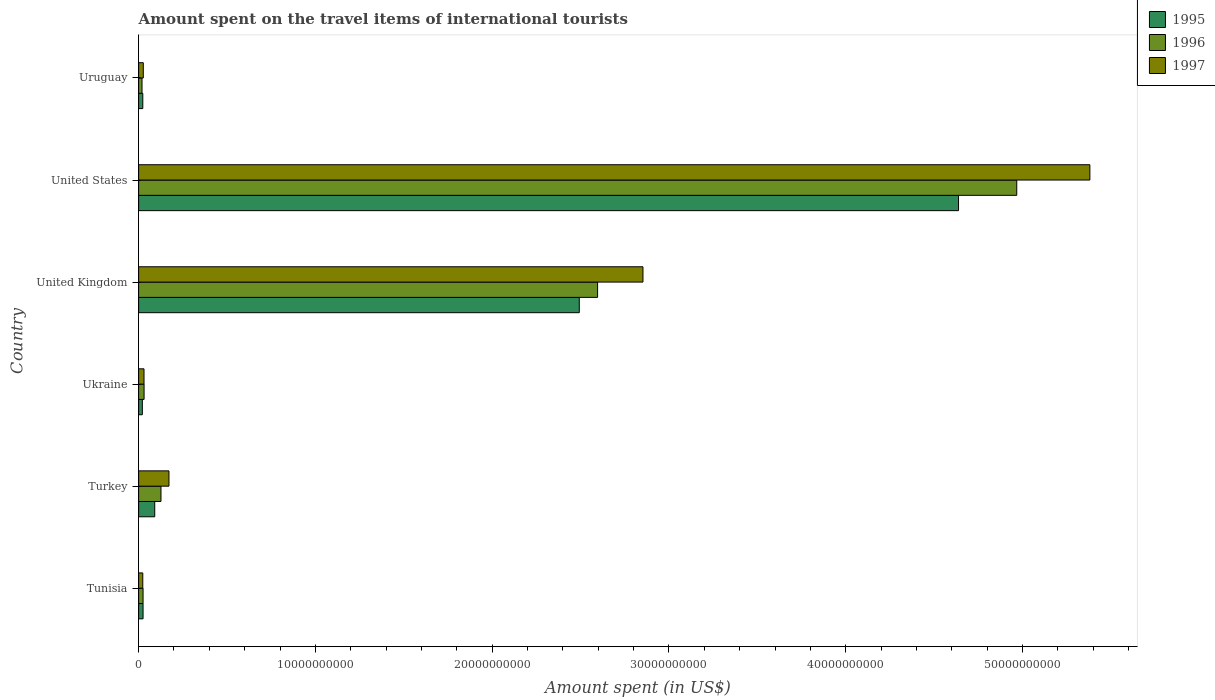How many different coloured bars are there?
Your answer should be very brief. 3. How many groups of bars are there?
Give a very brief answer. 6. How many bars are there on the 6th tick from the top?
Your response must be concise. 3. What is the label of the 3rd group of bars from the top?
Offer a very short reply. United Kingdom. What is the amount spent on the travel items of international tourists in 1996 in Turkey?
Offer a terse response. 1.26e+09. Across all countries, what is the maximum amount spent on the travel items of international tourists in 1996?
Provide a succinct answer. 4.97e+1. Across all countries, what is the minimum amount spent on the travel items of international tourists in 1996?
Your answer should be compact. 1.92e+08. In which country was the amount spent on the travel items of international tourists in 1996 minimum?
Offer a terse response. Uruguay. What is the total amount spent on the travel items of international tourists in 1995 in the graph?
Your response must be concise. 7.29e+1. What is the difference between the amount spent on the travel items of international tourists in 1996 in Ukraine and that in United Kingdom?
Ensure brevity in your answer.  -2.57e+1. What is the difference between the amount spent on the travel items of international tourists in 1997 in United Kingdom and the amount spent on the travel items of international tourists in 1995 in Turkey?
Offer a very short reply. 2.76e+1. What is the average amount spent on the travel items of international tourists in 1996 per country?
Ensure brevity in your answer.  1.29e+1. What is the difference between the amount spent on the travel items of international tourists in 1995 and amount spent on the travel items of international tourists in 1996 in Uruguay?
Offer a very short reply. 4.40e+07. What is the ratio of the amount spent on the travel items of international tourists in 1997 in Turkey to that in United Kingdom?
Make the answer very short. 0.06. What is the difference between the highest and the second highest amount spent on the travel items of international tourists in 1996?
Provide a succinct answer. 2.37e+1. What is the difference between the highest and the lowest amount spent on the travel items of international tourists in 1997?
Offer a very short reply. 5.36e+1. In how many countries, is the amount spent on the travel items of international tourists in 1996 greater than the average amount spent on the travel items of international tourists in 1996 taken over all countries?
Keep it short and to the point. 2. What does the 3rd bar from the top in Ukraine represents?
Make the answer very short. 1995. Are all the bars in the graph horizontal?
Provide a short and direct response. Yes. How many countries are there in the graph?
Your answer should be compact. 6. Are the values on the major ticks of X-axis written in scientific E-notation?
Your response must be concise. No. Does the graph contain any zero values?
Provide a succinct answer. No. Where does the legend appear in the graph?
Your answer should be compact. Top right. How many legend labels are there?
Your answer should be very brief. 3. How are the legend labels stacked?
Offer a very short reply. Vertical. What is the title of the graph?
Ensure brevity in your answer.  Amount spent on the travel items of international tourists. What is the label or title of the X-axis?
Keep it short and to the point. Amount spent (in US$). What is the Amount spent (in US$) in 1995 in Tunisia?
Provide a short and direct response. 2.51e+08. What is the Amount spent (in US$) in 1996 in Tunisia?
Your answer should be compact. 2.51e+08. What is the Amount spent (in US$) in 1997 in Tunisia?
Your answer should be compact. 2.35e+08. What is the Amount spent (in US$) in 1995 in Turkey?
Your answer should be very brief. 9.11e+08. What is the Amount spent (in US$) in 1996 in Turkey?
Provide a succinct answer. 1.26e+09. What is the Amount spent (in US$) of 1997 in Turkey?
Provide a short and direct response. 1.72e+09. What is the Amount spent (in US$) in 1995 in Ukraine?
Provide a succinct answer. 2.10e+08. What is the Amount spent (in US$) in 1996 in Ukraine?
Your response must be concise. 3.08e+08. What is the Amount spent (in US$) of 1997 in Ukraine?
Your answer should be very brief. 3.05e+08. What is the Amount spent (in US$) of 1995 in United Kingdom?
Keep it short and to the point. 2.49e+1. What is the Amount spent (in US$) in 1996 in United Kingdom?
Provide a short and direct response. 2.60e+1. What is the Amount spent (in US$) of 1997 in United Kingdom?
Give a very brief answer. 2.85e+1. What is the Amount spent (in US$) in 1995 in United States?
Your answer should be very brief. 4.64e+1. What is the Amount spent (in US$) in 1996 in United States?
Your answer should be very brief. 4.97e+1. What is the Amount spent (in US$) in 1997 in United States?
Your response must be concise. 5.38e+1. What is the Amount spent (in US$) in 1995 in Uruguay?
Your answer should be very brief. 2.36e+08. What is the Amount spent (in US$) of 1996 in Uruguay?
Provide a short and direct response. 1.92e+08. What is the Amount spent (in US$) of 1997 in Uruguay?
Give a very brief answer. 2.64e+08. Across all countries, what is the maximum Amount spent (in US$) in 1995?
Your response must be concise. 4.64e+1. Across all countries, what is the maximum Amount spent (in US$) in 1996?
Offer a very short reply. 4.97e+1. Across all countries, what is the maximum Amount spent (in US$) in 1997?
Your answer should be compact. 5.38e+1. Across all countries, what is the minimum Amount spent (in US$) in 1995?
Provide a succinct answer. 2.10e+08. Across all countries, what is the minimum Amount spent (in US$) of 1996?
Your response must be concise. 1.92e+08. Across all countries, what is the minimum Amount spent (in US$) of 1997?
Offer a very short reply. 2.35e+08. What is the total Amount spent (in US$) of 1995 in the graph?
Your response must be concise. 7.29e+1. What is the total Amount spent (in US$) of 1996 in the graph?
Your answer should be compact. 7.76e+1. What is the total Amount spent (in US$) in 1997 in the graph?
Your response must be concise. 8.49e+1. What is the difference between the Amount spent (in US$) of 1995 in Tunisia and that in Turkey?
Offer a very short reply. -6.60e+08. What is the difference between the Amount spent (in US$) of 1996 in Tunisia and that in Turkey?
Your answer should be very brief. -1.01e+09. What is the difference between the Amount spent (in US$) in 1997 in Tunisia and that in Turkey?
Give a very brief answer. -1.48e+09. What is the difference between the Amount spent (in US$) of 1995 in Tunisia and that in Ukraine?
Your response must be concise. 4.10e+07. What is the difference between the Amount spent (in US$) of 1996 in Tunisia and that in Ukraine?
Provide a succinct answer. -5.70e+07. What is the difference between the Amount spent (in US$) in 1997 in Tunisia and that in Ukraine?
Give a very brief answer. -7.00e+07. What is the difference between the Amount spent (in US$) of 1995 in Tunisia and that in United Kingdom?
Your response must be concise. -2.47e+1. What is the difference between the Amount spent (in US$) in 1996 in Tunisia and that in United Kingdom?
Offer a terse response. -2.57e+1. What is the difference between the Amount spent (in US$) of 1997 in Tunisia and that in United Kingdom?
Your answer should be compact. -2.83e+1. What is the difference between the Amount spent (in US$) in 1995 in Tunisia and that in United States?
Provide a succinct answer. -4.61e+1. What is the difference between the Amount spent (in US$) of 1996 in Tunisia and that in United States?
Offer a terse response. -4.94e+1. What is the difference between the Amount spent (in US$) in 1997 in Tunisia and that in United States?
Offer a very short reply. -5.36e+1. What is the difference between the Amount spent (in US$) of 1995 in Tunisia and that in Uruguay?
Give a very brief answer. 1.50e+07. What is the difference between the Amount spent (in US$) of 1996 in Tunisia and that in Uruguay?
Offer a very short reply. 5.90e+07. What is the difference between the Amount spent (in US$) of 1997 in Tunisia and that in Uruguay?
Provide a short and direct response. -2.90e+07. What is the difference between the Amount spent (in US$) of 1995 in Turkey and that in Ukraine?
Your response must be concise. 7.01e+08. What is the difference between the Amount spent (in US$) in 1996 in Turkey and that in Ukraine?
Ensure brevity in your answer.  9.57e+08. What is the difference between the Amount spent (in US$) of 1997 in Turkey and that in Ukraine?
Ensure brevity in your answer.  1.41e+09. What is the difference between the Amount spent (in US$) in 1995 in Turkey and that in United Kingdom?
Ensure brevity in your answer.  -2.40e+1. What is the difference between the Amount spent (in US$) in 1996 in Turkey and that in United Kingdom?
Your answer should be very brief. -2.47e+1. What is the difference between the Amount spent (in US$) of 1997 in Turkey and that in United Kingdom?
Your answer should be very brief. -2.68e+1. What is the difference between the Amount spent (in US$) in 1995 in Turkey and that in United States?
Make the answer very short. -4.55e+1. What is the difference between the Amount spent (in US$) of 1996 in Turkey and that in United States?
Give a very brief answer. -4.84e+1. What is the difference between the Amount spent (in US$) of 1997 in Turkey and that in United States?
Your response must be concise. -5.21e+1. What is the difference between the Amount spent (in US$) of 1995 in Turkey and that in Uruguay?
Offer a terse response. 6.75e+08. What is the difference between the Amount spent (in US$) in 1996 in Turkey and that in Uruguay?
Make the answer very short. 1.07e+09. What is the difference between the Amount spent (in US$) of 1997 in Turkey and that in Uruguay?
Keep it short and to the point. 1.45e+09. What is the difference between the Amount spent (in US$) of 1995 in Ukraine and that in United Kingdom?
Offer a very short reply. -2.47e+1. What is the difference between the Amount spent (in US$) of 1996 in Ukraine and that in United Kingdom?
Keep it short and to the point. -2.57e+1. What is the difference between the Amount spent (in US$) in 1997 in Ukraine and that in United Kingdom?
Offer a terse response. -2.82e+1. What is the difference between the Amount spent (in US$) of 1995 in Ukraine and that in United States?
Ensure brevity in your answer.  -4.62e+1. What is the difference between the Amount spent (in US$) of 1996 in Ukraine and that in United States?
Your answer should be compact. -4.94e+1. What is the difference between the Amount spent (in US$) of 1997 in Ukraine and that in United States?
Offer a very short reply. -5.35e+1. What is the difference between the Amount spent (in US$) in 1995 in Ukraine and that in Uruguay?
Your response must be concise. -2.60e+07. What is the difference between the Amount spent (in US$) in 1996 in Ukraine and that in Uruguay?
Give a very brief answer. 1.16e+08. What is the difference between the Amount spent (in US$) in 1997 in Ukraine and that in Uruguay?
Give a very brief answer. 4.10e+07. What is the difference between the Amount spent (in US$) in 1995 in United Kingdom and that in United States?
Your answer should be compact. -2.15e+1. What is the difference between the Amount spent (in US$) of 1996 in United Kingdom and that in United States?
Provide a short and direct response. -2.37e+1. What is the difference between the Amount spent (in US$) of 1997 in United Kingdom and that in United States?
Keep it short and to the point. -2.53e+1. What is the difference between the Amount spent (in US$) of 1995 in United Kingdom and that in Uruguay?
Give a very brief answer. 2.47e+1. What is the difference between the Amount spent (in US$) in 1996 in United Kingdom and that in Uruguay?
Offer a terse response. 2.58e+1. What is the difference between the Amount spent (in US$) in 1997 in United Kingdom and that in Uruguay?
Your answer should be very brief. 2.83e+1. What is the difference between the Amount spent (in US$) of 1995 in United States and that in Uruguay?
Offer a very short reply. 4.61e+1. What is the difference between the Amount spent (in US$) of 1996 in United States and that in Uruguay?
Your answer should be very brief. 4.95e+1. What is the difference between the Amount spent (in US$) in 1997 in United States and that in Uruguay?
Ensure brevity in your answer.  5.35e+1. What is the difference between the Amount spent (in US$) of 1995 in Tunisia and the Amount spent (in US$) of 1996 in Turkey?
Provide a short and direct response. -1.01e+09. What is the difference between the Amount spent (in US$) of 1995 in Tunisia and the Amount spent (in US$) of 1997 in Turkey?
Your answer should be compact. -1.46e+09. What is the difference between the Amount spent (in US$) of 1996 in Tunisia and the Amount spent (in US$) of 1997 in Turkey?
Your response must be concise. -1.46e+09. What is the difference between the Amount spent (in US$) in 1995 in Tunisia and the Amount spent (in US$) in 1996 in Ukraine?
Provide a succinct answer. -5.70e+07. What is the difference between the Amount spent (in US$) in 1995 in Tunisia and the Amount spent (in US$) in 1997 in Ukraine?
Give a very brief answer. -5.40e+07. What is the difference between the Amount spent (in US$) in 1996 in Tunisia and the Amount spent (in US$) in 1997 in Ukraine?
Offer a terse response. -5.40e+07. What is the difference between the Amount spent (in US$) in 1995 in Tunisia and the Amount spent (in US$) in 1996 in United Kingdom?
Make the answer very short. -2.57e+1. What is the difference between the Amount spent (in US$) in 1995 in Tunisia and the Amount spent (in US$) in 1997 in United Kingdom?
Make the answer very short. -2.83e+1. What is the difference between the Amount spent (in US$) in 1996 in Tunisia and the Amount spent (in US$) in 1997 in United Kingdom?
Your response must be concise. -2.83e+1. What is the difference between the Amount spent (in US$) in 1995 in Tunisia and the Amount spent (in US$) in 1996 in United States?
Ensure brevity in your answer.  -4.94e+1. What is the difference between the Amount spent (in US$) of 1995 in Tunisia and the Amount spent (in US$) of 1997 in United States?
Offer a terse response. -5.36e+1. What is the difference between the Amount spent (in US$) in 1996 in Tunisia and the Amount spent (in US$) in 1997 in United States?
Your response must be concise. -5.36e+1. What is the difference between the Amount spent (in US$) of 1995 in Tunisia and the Amount spent (in US$) of 1996 in Uruguay?
Your answer should be compact. 5.90e+07. What is the difference between the Amount spent (in US$) in 1995 in Tunisia and the Amount spent (in US$) in 1997 in Uruguay?
Keep it short and to the point. -1.30e+07. What is the difference between the Amount spent (in US$) of 1996 in Tunisia and the Amount spent (in US$) of 1997 in Uruguay?
Give a very brief answer. -1.30e+07. What is the difference between the Amount spent (in US$) of 1995 in Turkey and the Amount spent (in US$) of 1996 in Ukraine?
Your response must be concise. 6.03e+08. What is the difference between the Amount spent (in US$) in 1995 in Turkey and the Amount spent (in US$) in 1997 in Ukraine?
Make the answer very short. 6.06e+08. What is the difference between the Amount spent (in US$) in 1996 in Turkey and the Amount spent (in US$) in 1997 in Ukraine?
Offer a terse response. 9.60e+08. What is the difference between the Amount spent (in US$) in 1995 in Turkey and the Amount spent (in US$) in 1996 in United Kingdom?
Your response must be concise. -2.51e+1. What is the difference between the Amount spent (in US$) of 1995 in Turkey and the Amount spent (in US$) of 1997 in United Kingdom?
Provide a succinct answer. -2.76e+1. What is the difference between the Amount spent (in US$) of 1996 in Turkey and the Amount spent (in US$) of 1997 in United Kingdom?
Your answer should be compact. -2.73e+1. What is the difference between the Amount spent (in US$) of 1995 in Turkey and the Amount spent (in US$) of 1996 in United States?
Offer a terse response. -4.88e+1. What is the difference between the Amount spent (in US$) in 1995 in Turkey and the Amount spent (in US$) in 1997 in United States?
Make the answer very short. -5.29e+1. What is the difference between the Amount spent (in US$) of 1996 in Turkey and the Amount spent (in US$) of 1997 in United States?
Give a very brief answer. -5.25e+1. What is the difference between the Amount spent (in US$) of 1995 in Turkey and the Amount spent (in US$) of 1996 in Uruguay?
Offer a terse response. 7.19e+08. What is the difference between the Amount spent (in US$) of 1995 in Turkey and the Amount spent (in US$) of 1997 in Uruguay?
Provide a short and direct response. 6.47e+08. What is the difference between the Amount spent (in US$) of 1996 in Turkey and the Amount spent (in US$) of 1997 in Uruguay?
Give a very brief answer. 1.00e+09. What is the difference between the Amount spent (in US$) in 1995 in Ukraine and the Amount spent (in US$) in 1996 in United Kingdom?
Your response must be concise. -2.58e+1. What is the difference between the Amount spent (in US$) in 1995 in Ukraine and the Amount spent (in US$) in 1997 in United Kingdom?
Provide a short and direct response. -2.83e+1. What is the difference between the Amount spent (in US$) of 1996 in Ukraine and the Amount spent (in US$) of 1997 in United Kingdom?
Ensure brevity in your answer.  -2.82e+1. What is the difference between the Amount spent (in US$) of 1995 in Ukraine and the Amount spent (in US$) of 1996 in United States?
Keep it short and to the point. -4.95e+1. What is the difference between the Amount spent (in US$) in 1995 in Ukraine and the Amount spent (in US$) in 1997 in United States?
Your response must be concise. -5.36e+1. What is the difference between the Amount spent (in US$) in 1996 in Ukraine and the Amount spent (in US$) in 1997 in United States?
Provide a succinct answer. -5.35e+1. What is the difference between the Amount spent (in US$) of 1995 in Ukraine and the Amount spent (in US$) of 1996 in Uruguay?
Provide a succinct answer. 1.80e+07. What is the difference between the Amount spent (in US$) of 1995 in Ukraine and the Amount spent (in US$) of 1997 in Uruguay?
Your answer should be compact. -5.40e+07. What is the difference between the Amount spent (in US$) in 1996 in Ukraine and the Amount spent (in US$) in 1997 in Uruguay?
Your answer should be very brief. 4.40e+07. What is the difference between the Amount spent (in US$) in 1995 in United Kingdom and the Amount spent (in US$) in 1996 in United States?
Offer a terse response. -2.47e+1. What is the difference between the Amount spent (in US$) in 1995 in United Kingdom and the Amount spent (in US$) in 1997 in United States?
Ensure brevity in your answer.  -2.89e+1. What is the difference between the Amount spent (in US$) of 1996 in United Kingdom and the Amount spent (in US$) of 1997 in United States?
Keep it short and to the point. -2.78e+1. What is the difference between the Amount spent (in US$) in 1995 in United Kingdom and the Amount spent (in US$) in 1996 in Uruguay?
Your response must be concise. 2.47e+1. What is the difference between the Amount spent (in US$) of 1995 in United Kingdom and the Amount spent (in US$) of 1997 in Uruguay?
Keep it short and to the point. 2.47e+1. What is the difference between the Amount spent (in US$) in 1996 in United Kingdom and the Amount spent (in US$) in 1997 in Uruguay?
Your response must be concise. 2.57e+1. What is the difference between the Amount spent (in US$) of 1995 in United States and the Amount spent (in US$) of 1996 in Uruguay?
Ensure brevity in your answer.  4.62e+1. What is the difference between the Amount spent (in US$) in 1995 in United States and the Amount spent (in US$) in 1997 in Uruguay?
Ensure brevity in your answer.  4.61e+1. What is the difference between the Amount spent (in US$) of 1996 in United States and the Amount spent (in US$) of 1997 in Uruguay?
Keep it short and to the point. 4.94e+1. What is the average Amount spent (in US$) of 1995 per country?
Your response must be concise. 1.22e+1. What is the average Amount spent (in US$) in 1996 per country?
Your response must be concise. 1.29e+1. What is the average Amount spent (in US$) of 1997 per country?
Your answer should be very brief. 1.41e+1. What is the difference between the Amount spent (in US$) of 1995 and Amount spent (in US$) of 1997 in Tunisia?
Offer a terse response. 1.60e+07. What is the difference between the Amount spent (in US$) in 1996 and Amount spent (in US$) in 1997 in Tunisia?
Keep it short and to the point. 1.60e+07. What is the difference between the Amount spent (in US$) of 1995 and Amount spent (in US$) of 1996 in Turkey?
Your answer should be compact. -3.54e+08. What is the difference between the Amount spent (in US$) in 1995 and Amount spent (in US$) in 1997 in Turkey?
Ensure brevity in your answer.  -8.05e+08. What is the difference between the Amount spent (in US$) in 1996 and Amount spent (in US$) in 1997 in Turkey?
Your answer should be very brief. -4.51e+08. What is the difference between the Amount spent (in US$) in 1995 and Amount spent (in US$) in 1996 in Ukraine?
Your answer should be very brief. -9.80e+07. What is the difference between the Amount spent (in US$) in 1995 and Amount spent (in US$) in 1997 in Ukraine?
Provide a short and direct response. -9.50e+07. What is the difference between the Amount spent (in US$) of 1996 and Amount spent (in US$) of 1997 in Ukraine?
Provide a succinct answer. 3.00e+06. What is the difference between the Amount spent (in US$) of 1995 and Amount spent (in US$) of 1996 in United Kingdom?
Ensure brevity in your answer.  -1.04e+09. What is the difference between the Amount spent (in US$) in 1995 and Amount spent (in US$) in 1997 in United Kingdom?
Your answer should be very brief. -3.60e+09. What is the difference between the Amount spent (in US$) of 1996 and Amount spent (in US$) of 1997 in United Kingdom?
Offer a very short reply. -2.57e+09. What is the difference between the Amount spent (in US$) in 1995 and Amount spent (in US$) in 1996 in United States?
Give a very brief answer. -3.29e+09. What is the difference between the Amount spent (in US$) of 1995 and Amount spent (in US$) of 1997 in United States?
Make the answer very short. -7.43e+09. What is the difference between the Amount spent (in US$) of 1996 and Amount spent (in US$) of 1997 in United States?
Your answer should be very brief. -4.14e+09. What is the difference between the Amount spent (in US$) in 1995 and Amount spent (in US$) in 1996 in Uruguay?
Your answer should be very brief. 4.40e+07. What is the difference between the Amount spent (in US$) of 1995 and Amount spent (in US$) of 1997 in Uruguay?
Give a very brief answer. -2.80e+07. What is the difference between the Amount spent (in US$) in 1996 and Amount spent (in US$) in 1997 in Uruguay?
Offer a terse response. -7.20e+07. What is the ratio of the Amount spent (in US$) in 1995 in Tunisia to that in Turkey?
Keep it short and to the point. 0.28. What is the ratio of the Amount spent (in US$) in 1996 in Tunisia to that in Turkey?
Offer a very short reply. 0.2. What is the ratio of the Amount spent (in US$) of 1997 in Tunisia to that in Turkey?
Your response must be concise. 0.14. What is the ratio of the Amount spent (in US$) in 1995 in Tunisia to that in Ukraine?
Your answer should be compact. 1.2. What is the ratio of the Amount spent (in US$) of 1996 in Tunisia to that in Ukraine?
Offer a very short reply. 0.81. What is the ratio of the Amount spent (in US$) of 1997 in Tunisia to that in Ukraine?
Make the answer very short. 0.77. What is the ratio of the Amount spent (in US$) of 1995 in Tunisia to that in United Kingdom?
Your response must be concise. 0.01. What is the ratio of the Amount spent (in US$) in 1996 in Tunisia to that in United Kingdom?
Your answer should be compact. 0.01. What is the ratio of the Amount spent (in US$) in 1997 in Tunisia to that in United Kingdom?
Your answer should be compact. 0.01. What is the ratio of the Amount spent (in US$) of 1995 in Tunisia to that in United States?
Your answer should be compact. 0.01. What is the ratio of the Amount spent (in US$) of 1996 in Tunisia to that in United States?
Your answer should be very brief. 0.01. What is the ratio of the Amount spent (in US$) in 1997 in Tunisia to that in United States?
Provide a short and direct response. 0. What is the ratio of the Amount spent (in US$) in 1995 in Tunisia to that in Uruguay?
Your answer should be very brief. 1.06. What is the ratio of the Amount spent (in US$) of 1996 in Tunisia to that in Uruguay?
Keep it short and to the point. 1.31. What is the ratio of the Amount spent (in US$) in 1997 in Tunisia to that in Uruguay?
Ensure brevity in your answer.  0.89. What is the ratio of the Amount spent (in US$) in 1995 in Turkey to that in Ukraine?
Offer a terse response. 4.34. What is the ratio of the Amount spent (in US$) in 1996 in Turkey to that in Ukraine?
Your answer should be very brief. 4.11. What is the ratio of the Amount spent (in US$) in 1997 in Turkey to that in Ukraine?
Ensure brevity in your answer.  5.63. What is the ratio of the Amount spent (in US$) of 1995 in Turkey to that in United Kingdom?
Give a very brief answer. 0.04. What is the ratio of the Amount spent (in US$) in 1996 in Turkey to that in United Kingdom?
Provide a short and direct response. 0.05. What is the ratio of the Amount spent (in US$) in 1997 in Turkey to that in United Kingdom?
Ensure brevity in your answer.  0.06. What is the ratio of the Amount spent (in US$) of 1995 in Turkey to that in United States?
Make the answer very short. 0.02. What is the ratio of the Amount spent (in US$) in 1996 in Turkey to that in United States?
Your answer should be very brief. 0.03. What is the ratio of the Amount spent (in US$) of 1997 in Turkey to that in United States?
Keep it short and to the point. 0.03. What is the ratio of the Amount spent (in US$) of 1995 in Turkey to that in Uruguay?
Your answer should be very brief. 3.86. What is the ratio of the Amount spent (in US$) in 1996 in Turkey to that in Uruguay?
Offer a very short reply. 6.59. What is the ratio of the Amount spent (in US$) of 1997 in Turkey to that in Uruguay?
Give a very brief answer. 6.5. What is the ratio of the Amount spent (in US$) of 1995 in Ukraine to that in United Kingdom?
Provide a succinct answer. 0.01. What is the ratio of the Amount spent (in US$) in 1996 in Ukraine to that in United Kingdom?
Offer a terse response. 0.01. What is the ratio of the Amount spent (in US$) of 1997 in Ukraine to that in United Kingdom?
Provide a short and direct response. 0.01. What is the ratio of the Amount spent (in US$) of 1995 in Ukraine to that in United States?
Provide a short and direct response. 0. What is the ratio of the Amount spent (in US$) of 1996 in Ukraine to that in United States?
Give a very brief answer. 0.01. What is the ratio of the Amount spent (in US$) in 1997 in Ukraine to that in United States?
Offer a terse response. 0.01. What is the ratio of the Amount spent (in US$) in 1995 in Ukraine to that in Uruguay?
Offer a very short reply. 0.89. What is the ratio of the Amount spent (in US$) of 1996 in Ukraine to that in Uruguay?
Ensure brevity in your answer.  1.6. What is the ratio of the Amount spent (in US$) of 1997 in Ukraine to that in Uruguay?
Your answer should be compact. 1.16. What is the ratio of the Amount spent (in US$) in 1995 in United Kingdom to that in United States?
Provide a short and direct response. 0.54. What is the ratio of the Amount spent (in US$) in 1996 in United Kingdom to that in United States?
Give a very brief answer. 0.52. What is the ratio of the Amount spent (in US$) in 1997 in United Kingdom to that in United States?
Your answer should be very brief. 0.53. What is the ratio of the Amount spent (in US$) of 1995 in United Kingdom to that in Uruguay?
Your answer should be very brief. 105.62. What is the ratio of the Amount spent (in US$) in 1996 in United Kingdom to that in Uruguay?
Your response must be concise. 135.22. What is the ratio of the Amount spent (in US$) in 1997 in United Kingdom to that in Uruguay?
Your answer should be very brief. 108.06. What is the ratio of the Amount spent (in US$) in 1995 in United States to that in Uruguay?
Offer a very short reply. 196.52. What is the ratio of the Amount spent (in US$) of 1996 in United States to that in Uruguay?
Offer a very short reply. 258.71. What is the ratio of the Amount spent (in US$) of 1997 in United States to that in Uruguay?
Keep it short and to the point. 203.82. What is the difference between the highest and the second highest Amount spent (in US$) in 1995?
Your answer should be compact. 2.15e+1. What is the difference between the highest and the second highest Amount spent (in US$) in 1996?
Offer a very short reply. 2.37e+1. What is the difference between the highest and the second highest Amount spent (in US$) of 1997?
Offer a terse response. 2.53e+1. What is the difference between the highest and the lowest Amount spent (in US$) of 1995?
Provide a short and direct response. 4.62e+1. What is the difference between the highest and the lowest Amount spent (in US$) of 1996?
Give a very brief answer. 4.95e+1. What is the difference between the highest and the lowest Amount spent (in US$) of 1997?
Your response must be concise. 5.36e+1. 